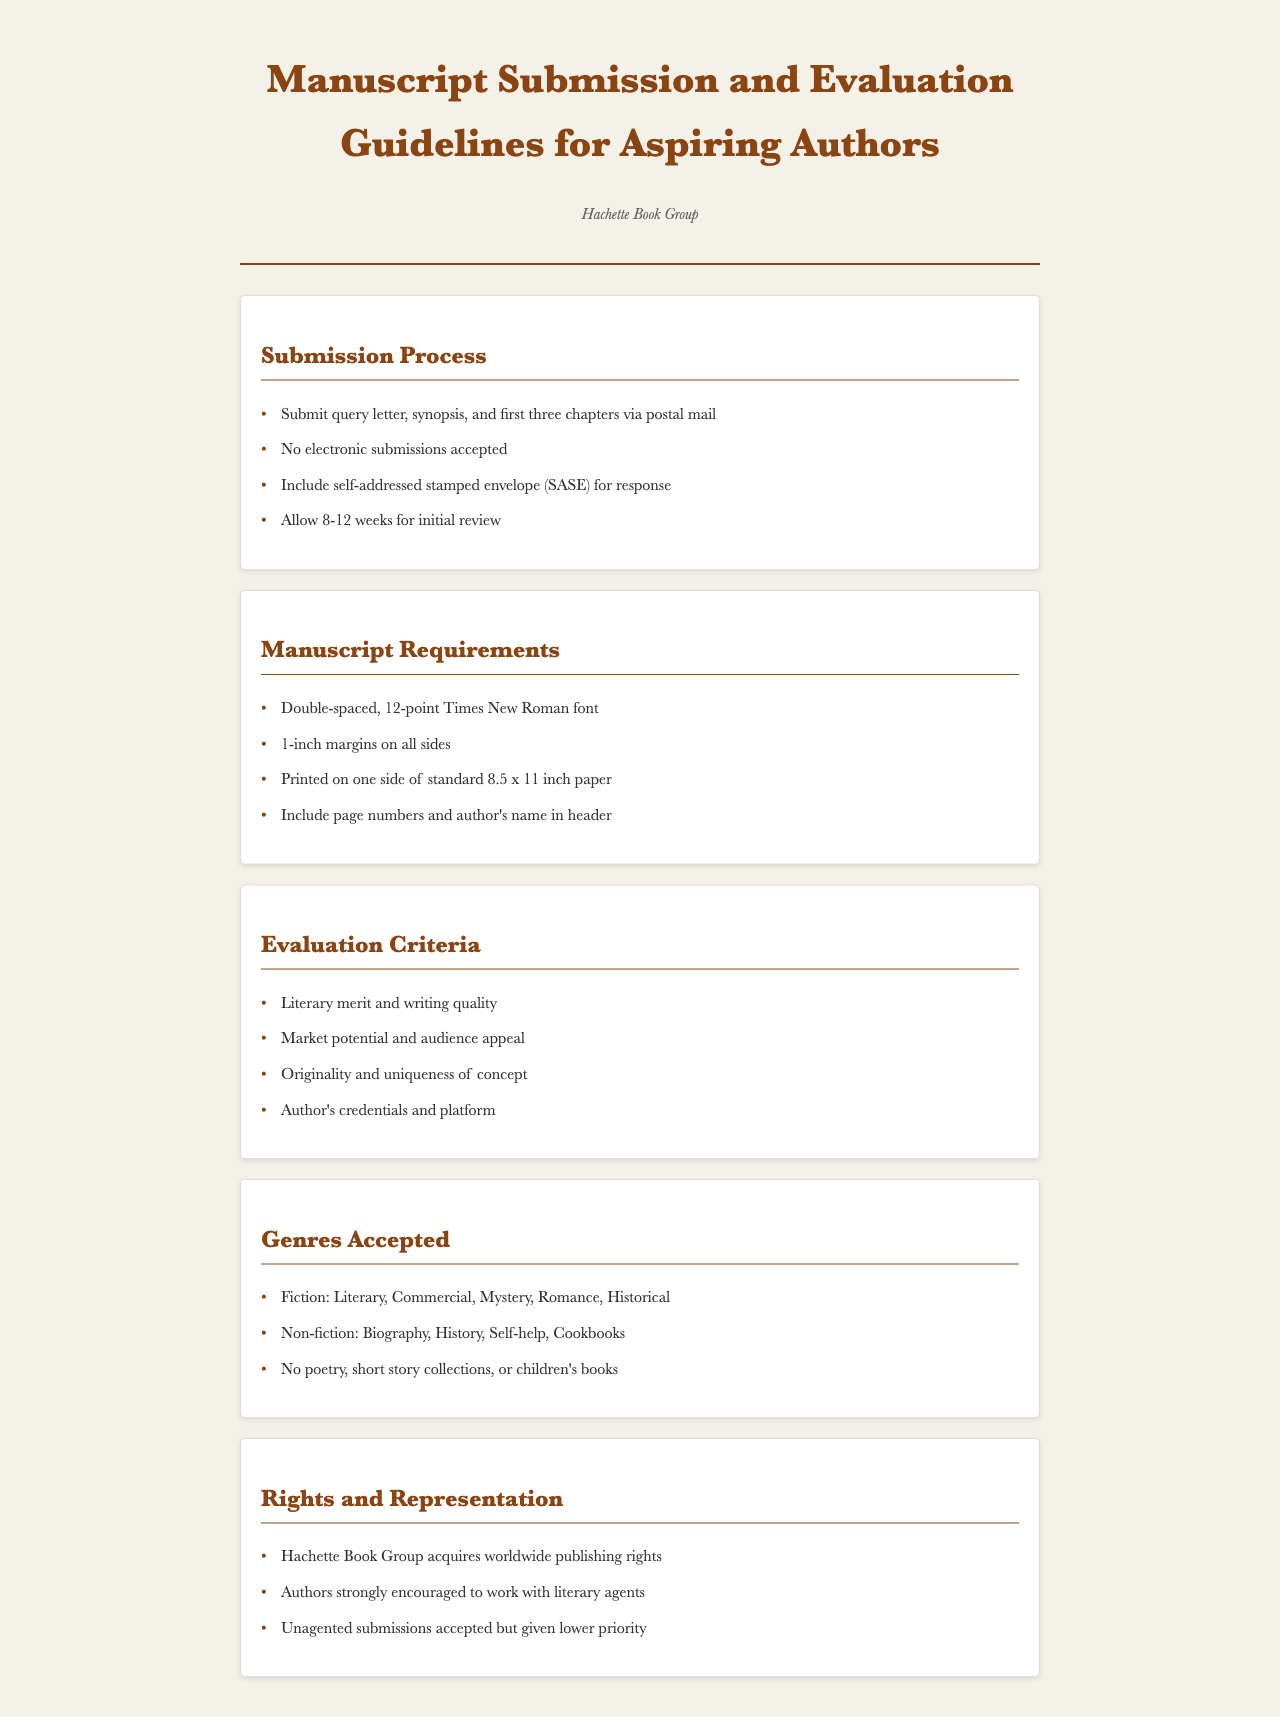what is the submission method for manuscripts? The document states that manuscripts should be submitted via postal mail, not electronically.
Answer: postal mail how many weeks should authors allow for an initial review? Authors are advised to allow a time frame for initial review as specified in the guidelines.
Answer: 8-12 weeks what font and size are required for the manuscript? The document requires a specific font and size for the manuscript formatting.
Answer: 12-point Times New Roman which genres are accepted according to the guidelines? The guidelines provide a list of genres that are accepted for submission.
Answer: Fiction: Literary, Commercial, Mystery, Romance, Historical; Non-fiction: Biography, History, Self-help, Cookbooks who is encouraged to assist authors in the submission process? The guidelines mention a recommendation regarding representation for authors.
Answer: literary agents what is a required element to include with the submission? A specific item is mentioned that authors must include with their manuscript submissions.
Answer: self-addressed stamped envelope (SASE) what criteria evaluates the manuscripts? The document outlines specific criteria that are used to evaluate submitted manuscripts.
Answer: Literary merit and writing quality do they accept poetry submissions? The guidelines clearly state the types of manuscript submissions that are not accepted.
Answer: No what printing specifications must the manuscript adhere to? The document details the specific printing requirements for manuscripts.
Answer: Printed on one side of standard 8.5 x 11 inch paper 